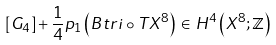Convert formula to latex. <formula><loc_0><loc_0><loc_500><loc_500>[ G _ { 4 } ] + \frac { 1 } { 4 } p _ { 1 } \left ( B t r i \circ T X ^ { 8 } \right ) \, \in \, H ^ { 4 } \left ( X ^ { 8 } ; \mathbb { Z } \right )</formula> 